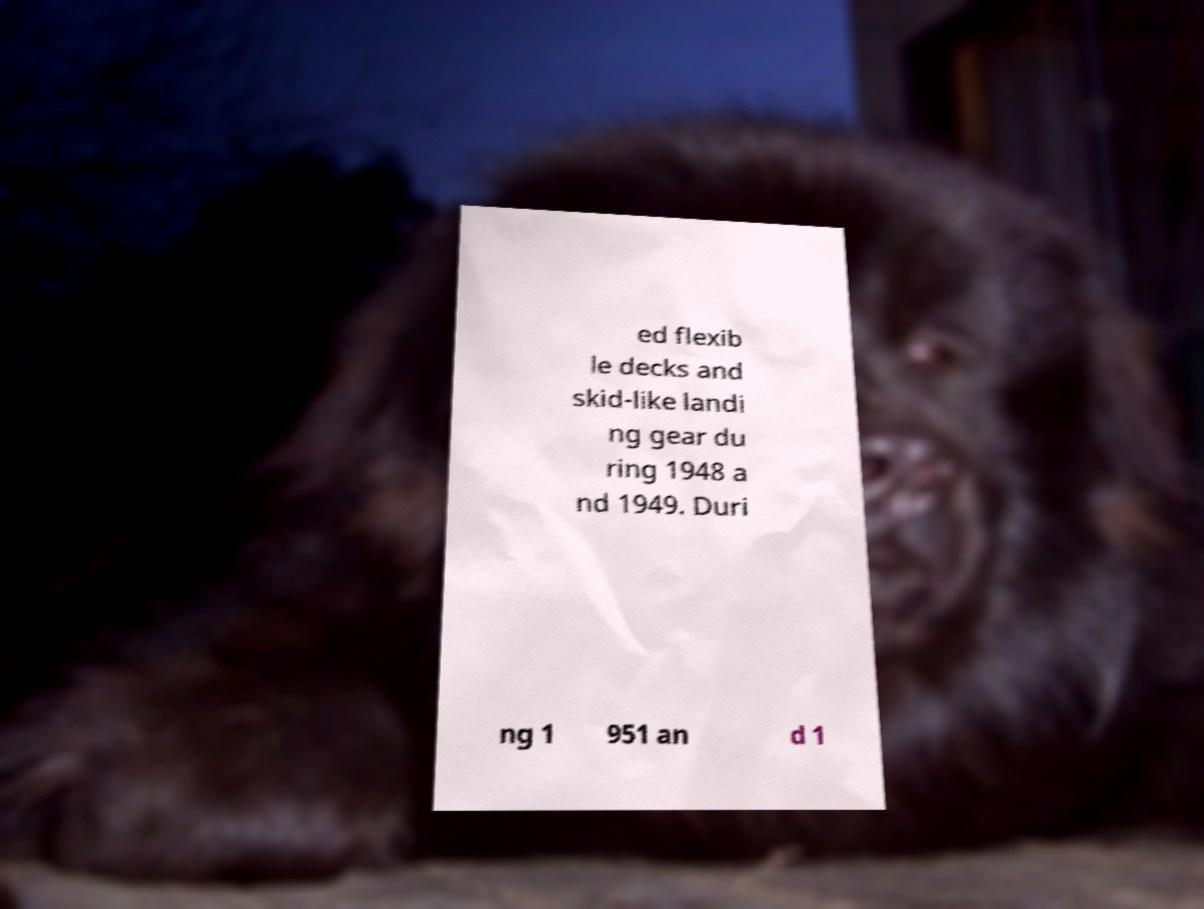Please identify and transcribe the text found in this image. ed flexib le decks and skid-like landi ng gear du ring 1948 a nd 1949. Duri ng 1 951 an d 1 